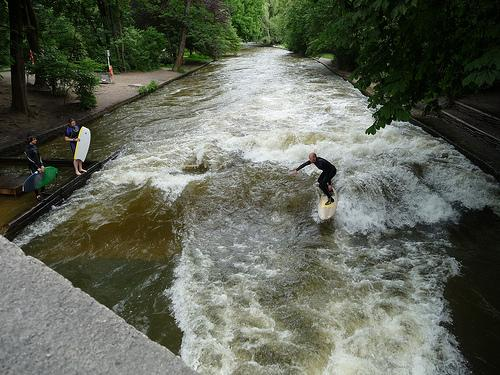Craft a sentence for a product advertisement promoting the surfboard that the man is surfing on. Experience the thrill of riding the waves on our sturdy and reliable white surfboard, perfect for riders of all skill levels! In a referential expression grounding task, connect the man wearing a black wetsuit and what he is doing in the image. The man in a black wetsuit is standing on a surfboard and catching a wave on the brown water. For a visual entailment task, list three visual relationships observed in the image. 3. The water has white water waves and is brown in color. Make an assumption about the people's proficiency in the image based on their surfboards and wetsuits. The people in the image seem to be experienced in surfing and water sports due to their professional-looking surfboards and wetsuits. What type of clothing are the persons interacting with surfboards wearing? The persons are wearing wetsuits of different colors such as blue, black, and black and blue combinations. Based on the image, describe the environment where the photo was taken. The photo was taken in the daytime by a river with brown water, white waves, and a shoreline with trees in the background. Write a question for a multi-choice VQA task and provide the correct answer. C. Yellow What is the most remarkable feature of the water in the image? The water is brown in color and has white waves. Describe the surfboard held by the man holding a green and blue board. The surfboard has green and blue colors with a unique design, suitable for water activities and sports. Identify the color and type of surfboard held by the person with dark hair. The person with dark hair is holding a green and blue board. 